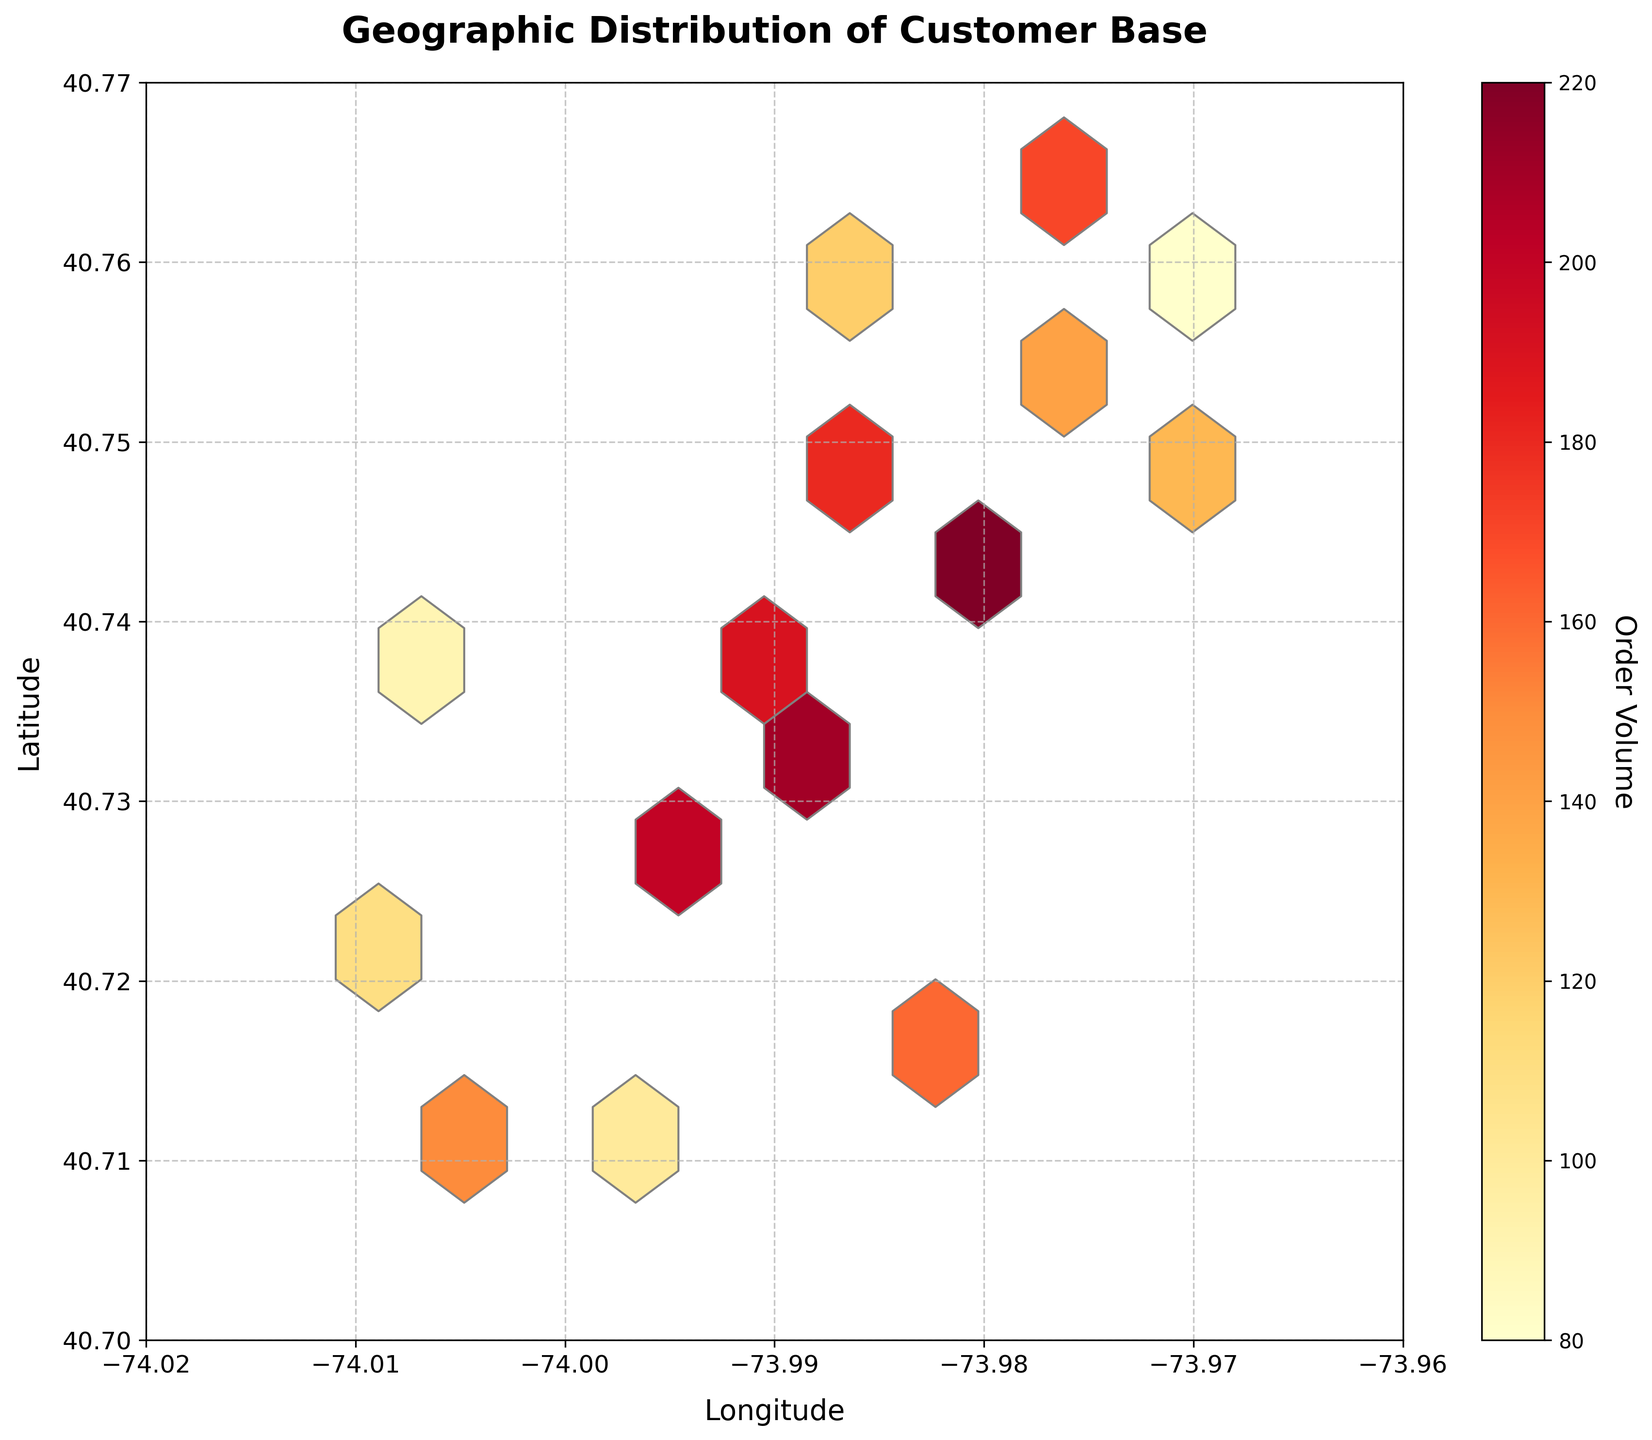what is the title of this plot? The title of the plot is prominently displayed at the top. The font size is large, making it easy to read.
Answer: Geographic Distribution of Customer Base what are the labels on the x and y axes? The labels for the axes are clearly provided as text next to the respective axes. The x-axis is labeled 'Longitude' and the y-axis is labeled 'Latitude'.
Answer: Longitude, Latitude which location has the highest order volume? To determine the highest order volume, look for the hexbin with the most intense color, which represents higher values as per the color bar on the side.
Answer: The area around (40.7431, -73.9800) what is the range of longitudes displayed in the plot? The extremes of the x-axis provide the range of longitudes. The x-axis runs from -74.02 to -73.96 as shown by the tick marks and axis labels.
Answer: -74.02 to -73.96 compare the order volumes around the center and peripheral regions of the plot. Compare the color density in the central region with the areas towards the edges. Central areas tend to have denser and more intense colors indicating higher order volumes.
Answer: Central regions have higher order volumes what can be inferred from the color bar on the right side of the plot? The color bar indicates the intensity or density of order volumes, where lighter colors represent lower volumes and darker colors represent higher volumes. This helps in quicker visual analysis of different areas.
Answer: It shows order volume intensity what do the denser hexagons represent? Denser hexagons with darker colors indicate areas with higher order volumes, as per the color-coded scale provided by the color bar.
Answer: Higher order volumes how many distinct hexbin clusters are visible in the plot? Count the visible hexbin clusters based on color variations visible across the plot. Highlighted clusters typically indicate geographic concentration of order volume.
Answer: Around 7-9 clusters what’s the general trend of order volumes from west to east? Observing the change in color density from the left side (west) to the right side (east), we can infer if order volumes increase, decrease, or remain constant.
Answer: Order volumes increase towards the east how does the grid size affect the density representation in the hexbin plot? A smaller grid size would show more precise and dense clusters while a larger grid size would make the clusters broader and less detailed. The current gridsize is set to 10, depicting medium density clusters.
Answer: Shows medium density with grid size 10 